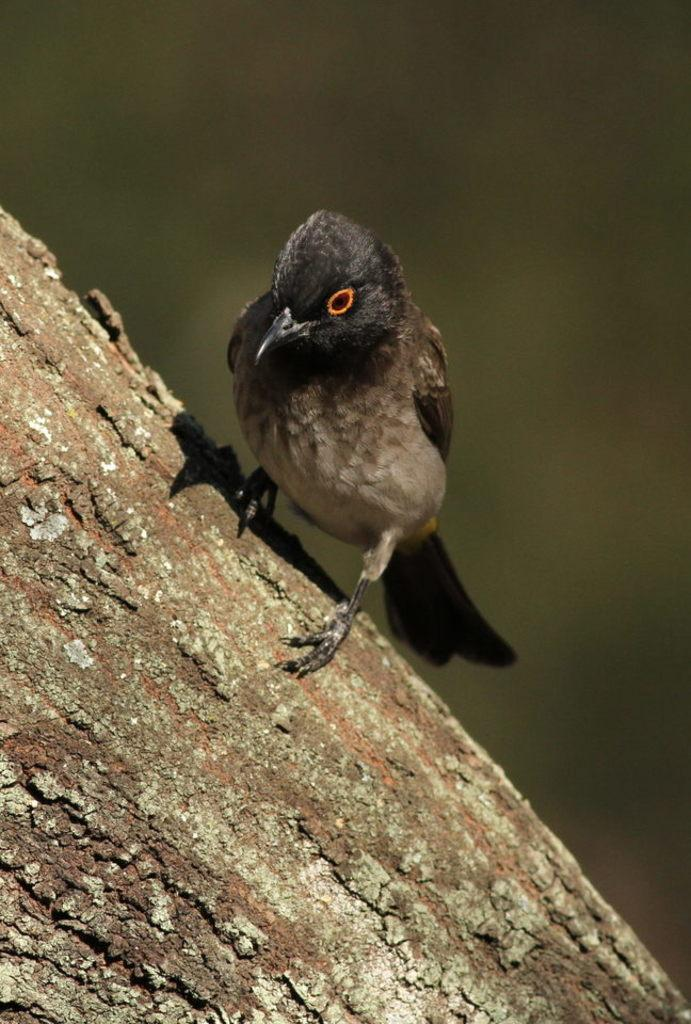What type of animal can be seen in the image? There is a bird in the image. Where is the bird located? The bird is on the trunk of a tree. What type of legal advice is the bird providing to the tiger in the image? There is no tiger or lawyer present in the image, and therefore no such interaction can be observed. 